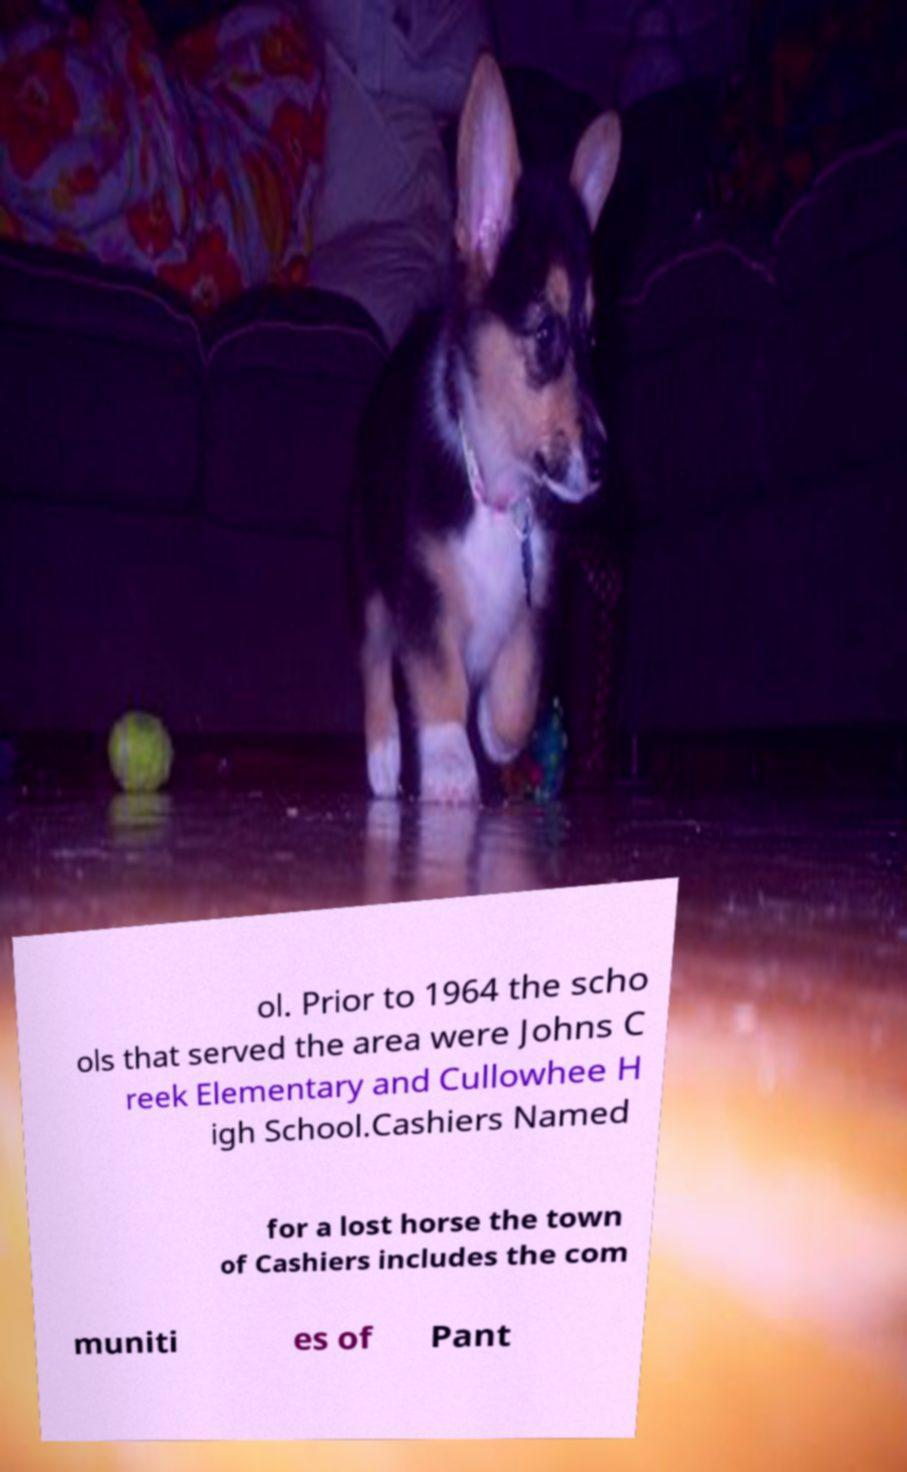I need the written content from this picture converted into text. Can you do that? ol. Prior to 1964 the scho ols that served the area were Johns C reek Elementary and Cullowhee H igh School.Cashiers Named for a lost horse the town of Cashiers includes the com muniti es of Pant 